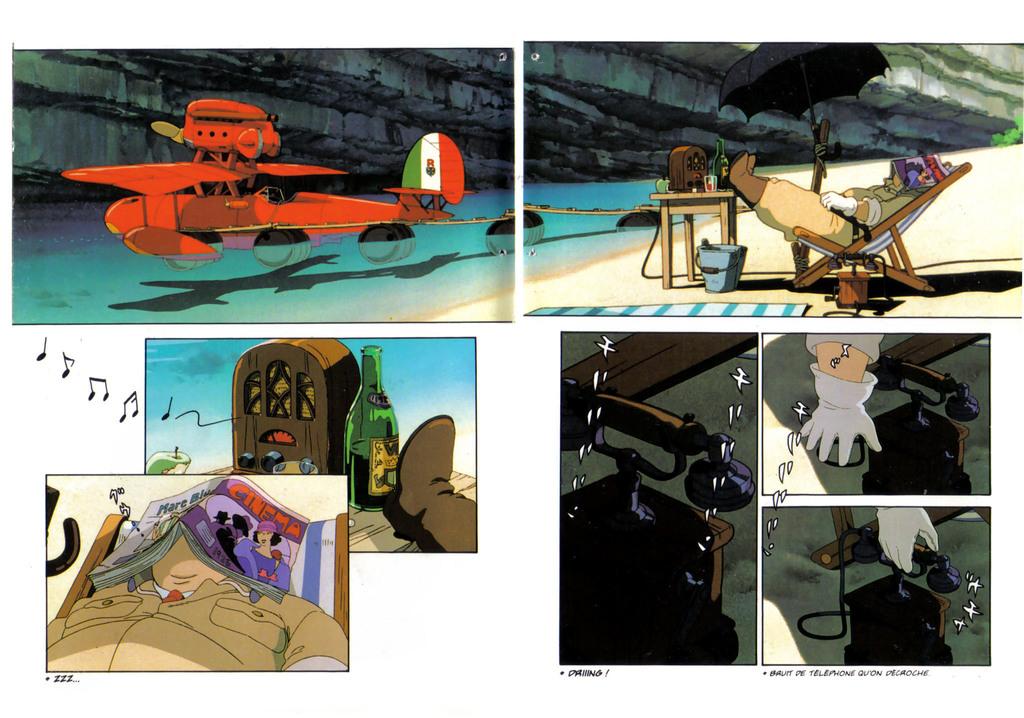What is the name of the magazine the sleeping man was reading?
Your answer should be very brief. Cinema. 